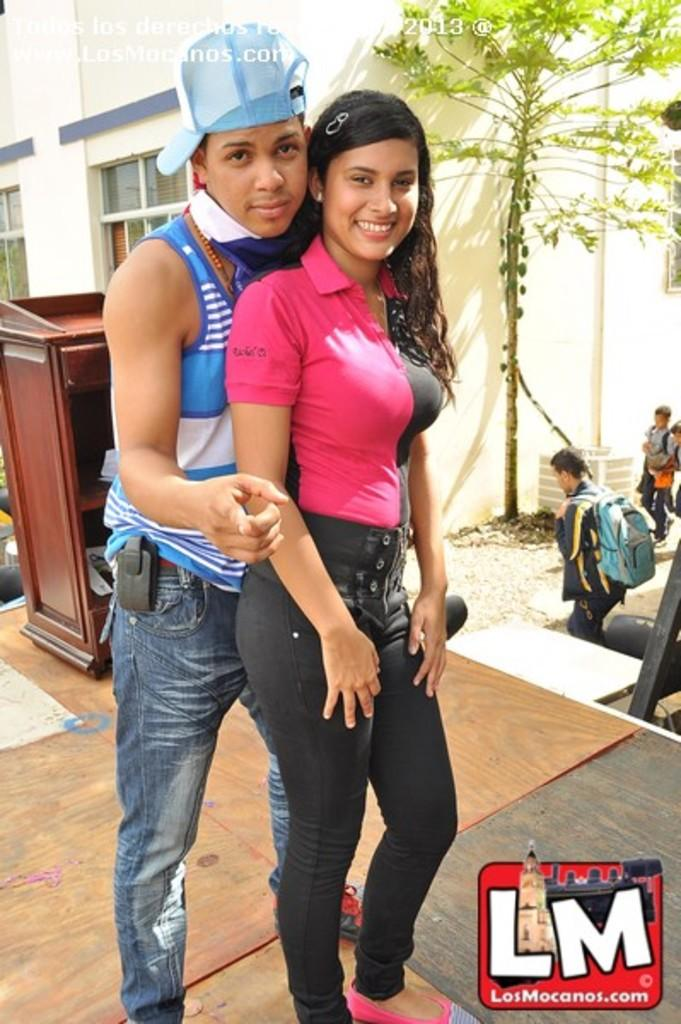Who is present in the image? There is a lady and a guy wearing a hat in the image. What can be seen in the background of the image? There are trees and a building in the image. How many people are in the image? There are people in the image, including the lady and the guy wearing a hat. What object can be used for work or study in the image? There is a desk in the image. What news is being reported on the houses in the image? There are no houses or news reports present in the image. 